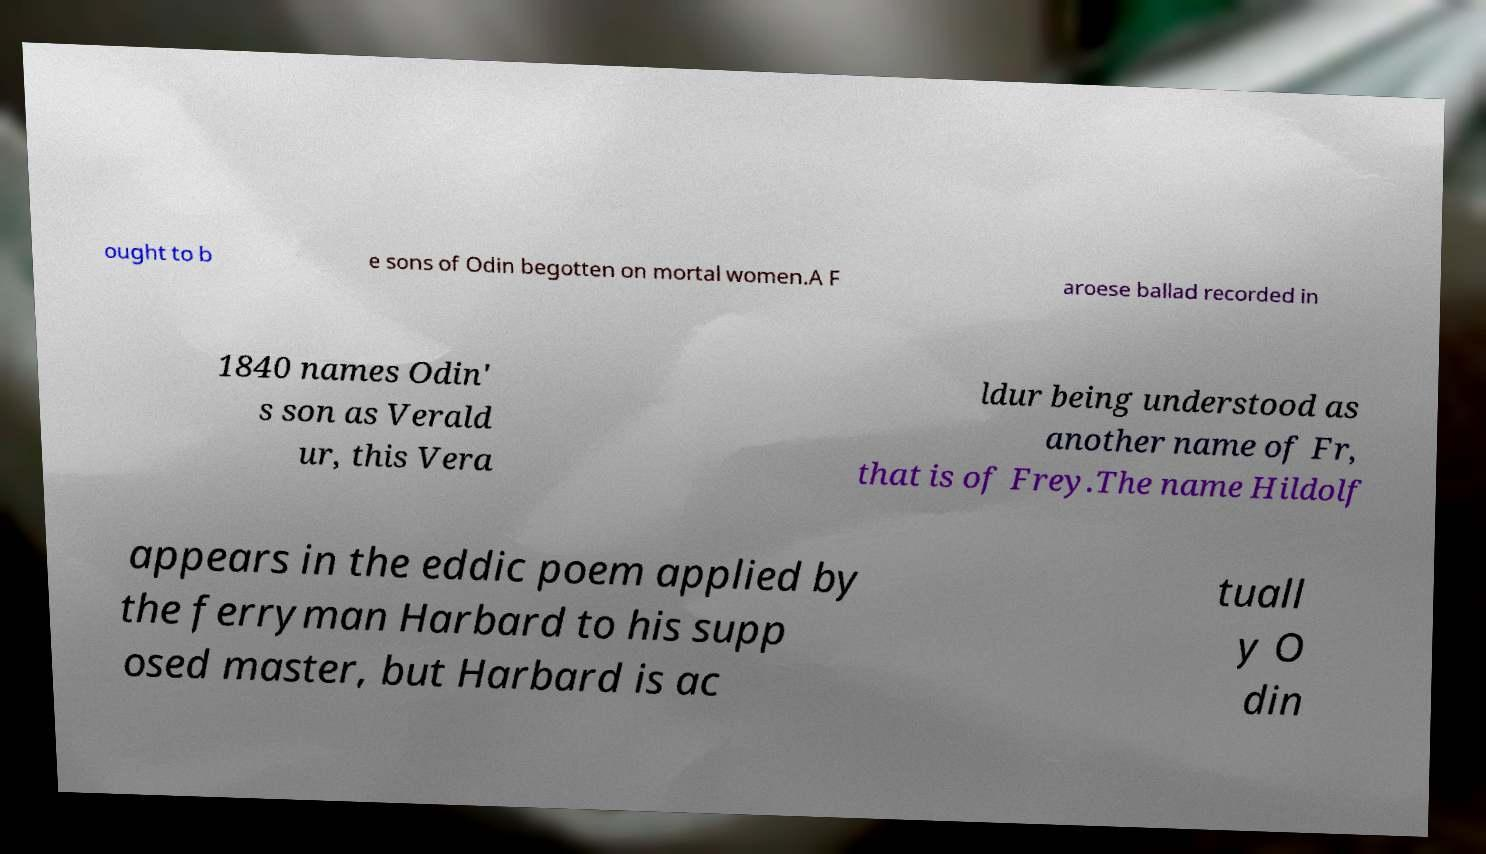Could you assist in decoding the text presented in this image and type it out clearly? ought to b e sons of Odin begotten on mortal women.A F aroese ballad recorded in 1840 names Odin' s son as Verald ur, this Vera ldur being understood as another name of Fr, that is of Frey.The name Hildolf appears in the eddic poem applied by the ferryman Harbard to his supp osed master, but Harbard is ac tuall y O din 